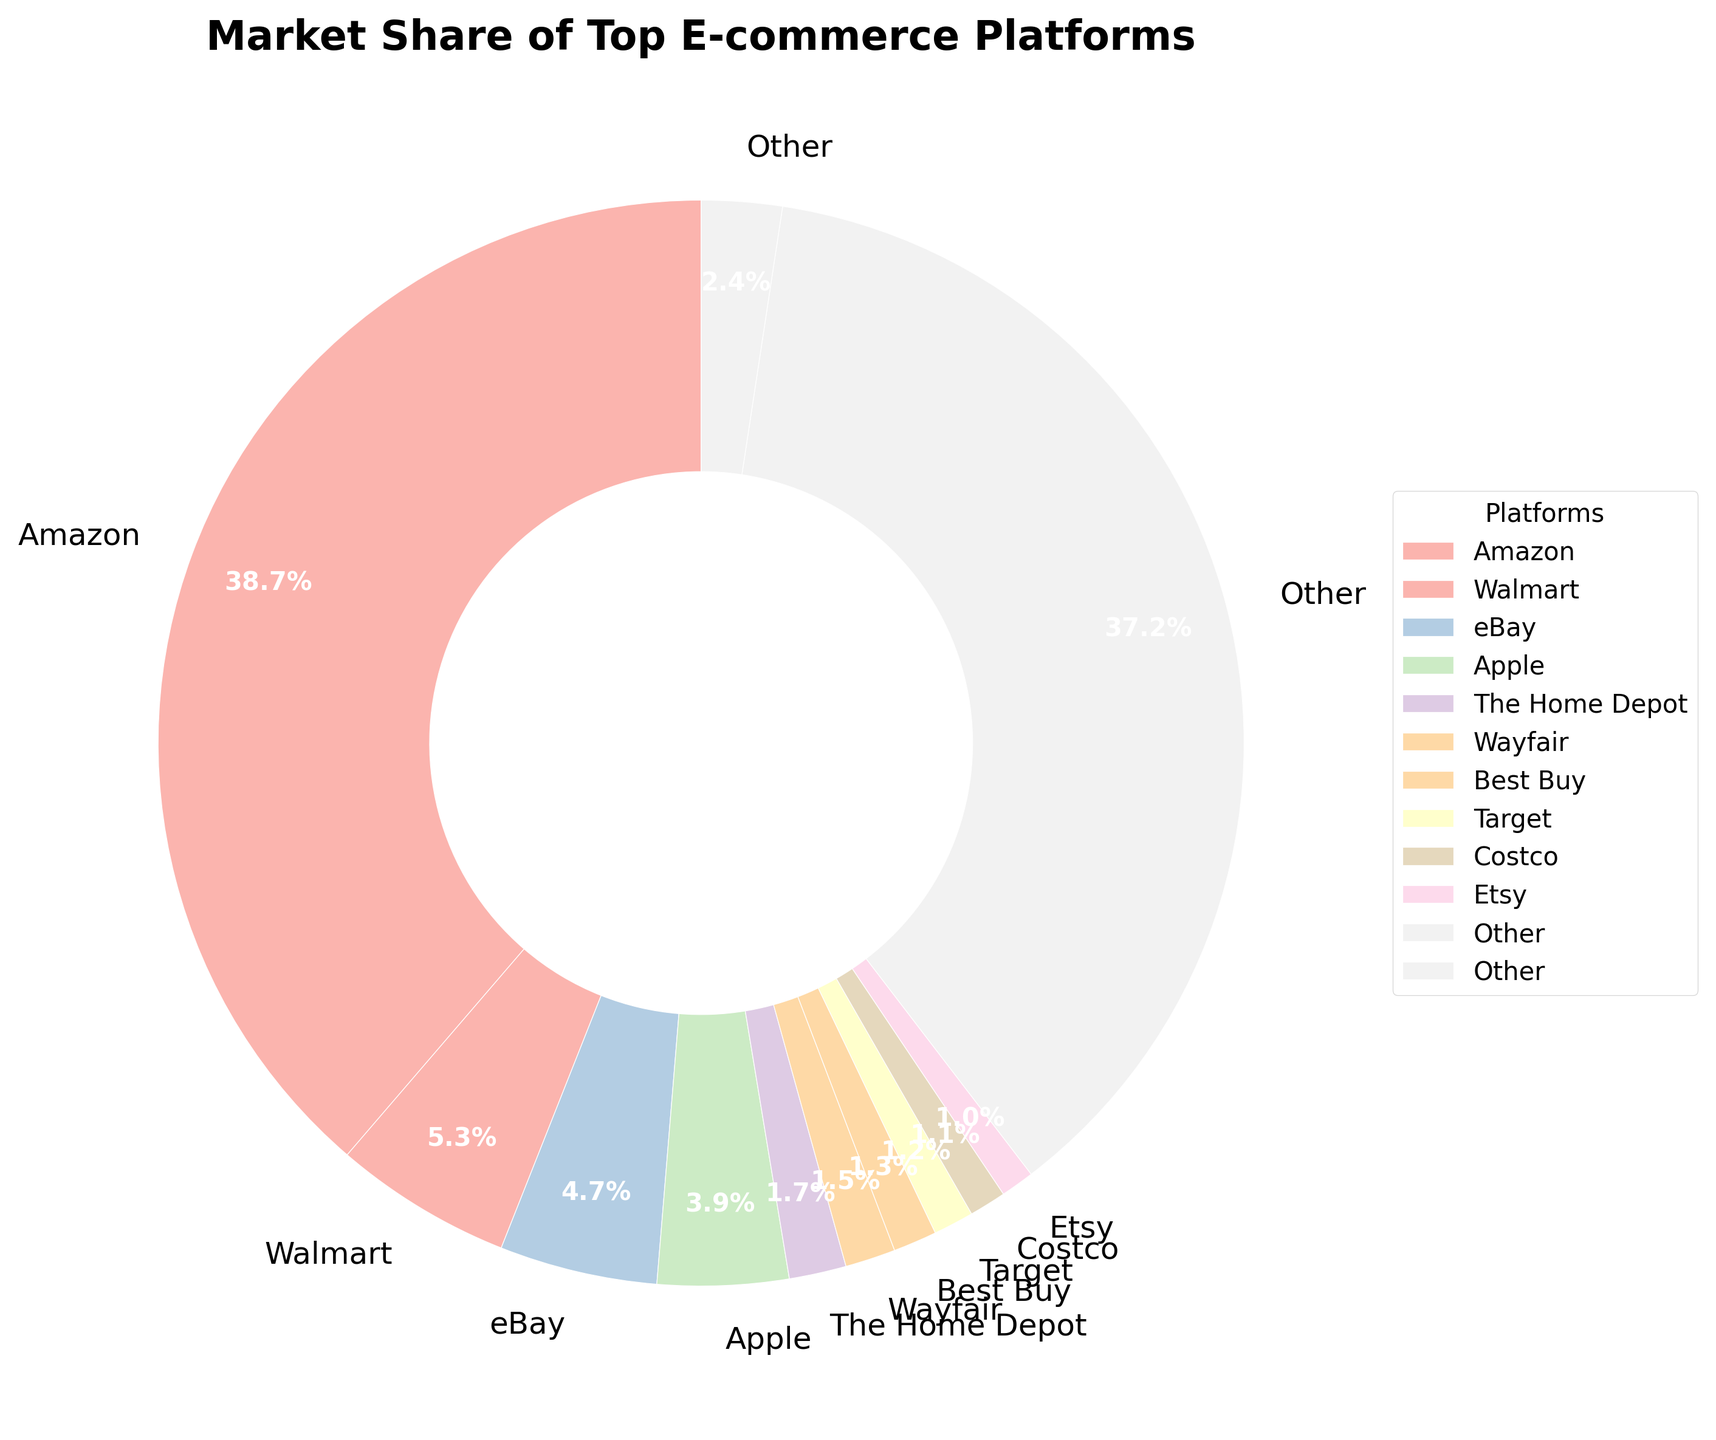Which platform has the largest market share? By looking at the figure, we can see that Amazon occupies the largest section of the pie chart.
Answer: Amazon What is the combined market share of Walmart, eBay, and Apple? Summing the market shares of Walmart (5.3%), eBay (4.7%), and Apple (3.9%) gives 5.3 + 4.7 + 3.9 = 13.9%.
Answer: 13.9% How does the market share of Amazon compare to that of Walmart? Amazon's market share is 38.7%, while Walmart's market share is 5.3%. Amazon's market share is much larger.
Answer: Amazon's market share is larger What is the total market share of platforms with less than 1% share each? The "Other" category in the pie chart represents platforms with less than 1% share each, and its total share is 37.2%.
Answer: 37.2% Which platform has a market share closest to 1% but greater than 1%? By examining the figure, we see that Costco has a market share of 1.1%, which is the smallest share above 1%.
Answer: Costco How many platforms have a market share between 1% and 2%? Examining the figure, platforms with market shares between 1% and 2% include The Home Depot (1.7%), Wayfair (1.5%), Best Buy (1.3%), Target (1.2%), and Costco (1.1%), making a total of 5 platforms.
Answer: 5 What is the difference in market share between Amazon and the 'Other' category? The market share of Amazon is 38.7%, and the market share of 'Other' is 37.2%. The difference is 38.7 - 37.2 = 1.5%.
Answer: 1.5% Which platform has a smaller market share than Etsy but larger than Macy's? Etsy has a market share of 1.0%, while Macy's has a market share of 0.6%. Chewy, with a market share of 0.9%, fits this condition.
Answer: Chewy What is the sum of market shares of the top three platforms? The top three platforms by market share are Amazon (38.7%), Walmart (5.3%), and eBay (4.7%). Their combined market share is 38.7 + 5.3 + 4.7 = 48.7%.
Answer: 48.7% Which platform’s market share is approximately one-third of Amazon’s market share? Amazon's market share is 38.7%. One-third of this is approximately 38.7 / 3 ≈ 12.9%. None of the individual platforms have this share, but the combined share of multiple platforms could be compared.
Answer: None 